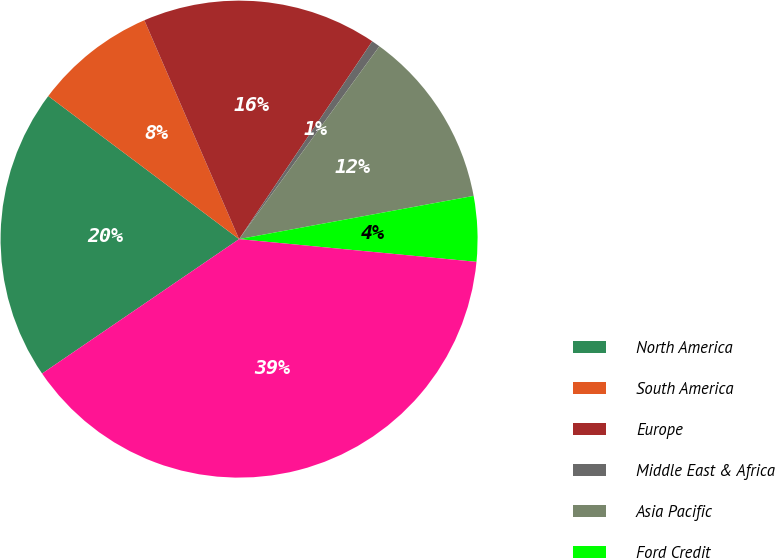<chart> <loc_0><loc_0><loc_500><loc_500><pie_chart><fcel>North America<fcel>South America<fcel>Europe<fcel>Middle East & Africa<fcel>Asia Pacific<fcel>Ford Credit<fcel>Total<nl><fcel>19.77%<fcel>8.26%<fcel>15.93%<fcel>0.58%<fcel>12.09%<fcel>4.42%<fcel>38.95%<nl></chart> 